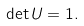<formula> <loc_0><loc_0><loc_500><loc_500>\det U = 1 .</formula> 